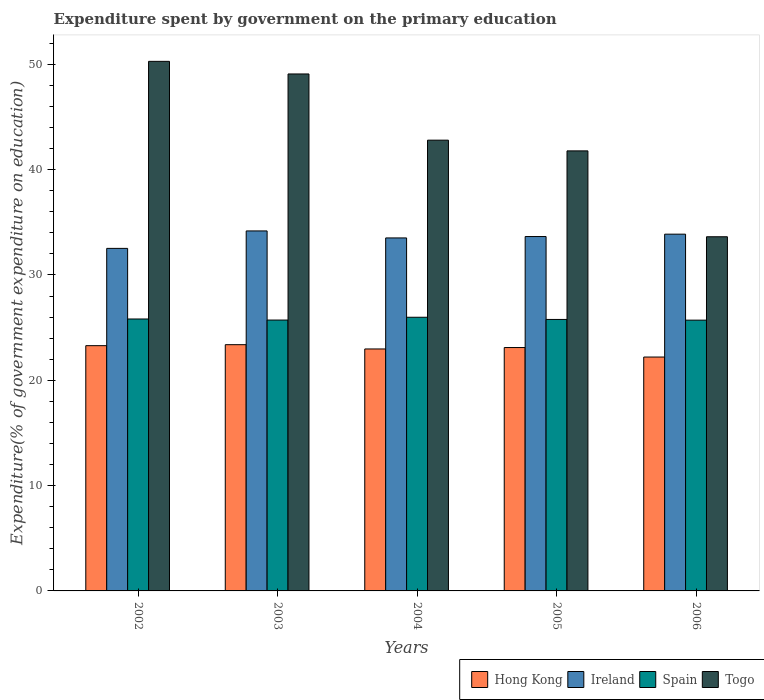How many groups of bars are there?
Offer a terse response. 5. Are the number of bars per tick equal to the number of legend labels?
Offer a very short reply. Yes. How many bars are there on the 1st tick from the left?
Provide a short and direct response. 4. What is the label of the 5th group of bars from the left?
Provide a short and direct response. 2006. In how many cases, is the number of bars for a given year not equal to the number of legend labels?
Your response must be concise. 0. What is the expenditure spent by government on the primary education in Ireland in 2002?
Offer a terse response. 32.52. Across all years, what is the maximum expenditure spent by government on the primary education in Togo?
Offer a terse response. 50.28. Across all years, what is the minimum expenditure spent by government on the primary education in Togo?
Provide a short and direct response. 33.63. In which year was the expenditure spent by government on the primary education in Togo maximum?
Provide a short and direct response. 2002. In which year was the expenditure spent by government on the primary education in Ireland minimum?
Ensure brevity in your answer.  2002. What is the total expenditure spent by government on the primary education in Ireland in the graph?
Offer a terse response. 167.73. What is the difference between the expenditure spent by government on the primary education in Ireland in 2002 and that in 2004?
Your answer should be compact. -0.99. What is the difference between the expenditure spent by government on the primary education in Hong Kong in 2005 and the expenditure spent by government on the primary education in Ireland in 2004?
Keep it short and to the point. -10.41. What is the average expenditure spent by government on the primary education in Togo per year?
Offer a very short reply. 43.51. In the year 2005, what is the difference between the expenditure spent by government on the primary education in Hong Kong and expenditure spent by government on the primary education in Togo?
Your response must be concise. -18.67. In how many years, is the expenditure spent by government on the primary education in Spain greater than 32 %?
Your answer should be compact. 0. What is the ratio of the expenditure spent by government on the primary education in Hong Kong in 2003 to that in 2006?
Make the answer very short. 1.05. Is the expenditure spent by government on the primary education in Hong Kong in 2002 less than that in 2003?
Make the answer very short. Yes. What is the difference between the highest and the second highest expenditure spent by government on the primary education in Hong Kong?
Keep it short and to the point. 0.09. What is the difference between the highest and the lowest expenditure spent by government on the primary education in Spain?
Ensure brevity in your answer.  0.28. Is the sum of the expenditure spent by government on the primary education in Ireland in 2003 and 2006 greater than the maximum expenditure spent by government on the primary education in Togo across all years?
Offer a very short reply. Yes. What does the 3rd bar from the left in 2004 represents?
Your response must be concise. Spain. What does the 4th bar from the right in 2004 represents?
Your answer should be very brief. Hong Kong. How many bars are there?
Give a very brief answer. 20. Are all the bars in the graph horizontal?
Make the answer very short. No. How many legend labels are there?
Your response must be concise. 4. How are the legend labels stacked?
Give a very brief answer. Horizontal. What is the title of the graph?
Your response must be concise. Expenditure spent by government on the primary education. Does "Ghana" appear as one of the legend labels in the graph?
Make the answer very short. No. What is the label or title of the Y-axis?
Your answer should be very brief. Expenditure(% of government expenditure on education). What is the Expenditure(% of government expenditure on education) in Hong Kong in 2002?
Give a very brief answer. 23.29. What is the Expenditure(% of government expenditure on education) of Ireland in 2002?
Provide a succinct answer. 32.52. What is the Expenditure(% of government expenditure on education) in Spain in 2002?
Provide a short and direct response. 25.82. What is the Expenditure(% of government expenditure on education) of Togo in 2002?
Provide a succinct answer. 50.28. What is the Expenditure(% of government expenditure on education) in Hong Kong in 2003?
Keep it short and to the point. 23.38. What is the Expenditure(% of government expenditure on education) of Ireland in 2003?
Offer a terse response. 34.18. What is the Expenditure(% of government expenditure on education) in Spain in 2003?
Ensure brevity in your answer.  25.72. What is the Expenditure(% of government expenditure on education) in Togo in 2003?
Your answer should be very brief. 49.08. What is the Expenditure(% of government expenditure on education) of Hong Kong in 2004?
Offer a terse response. 22.97. What is the Expenditure(% of government expenditure on education) in Ireland in 2004?
Offer a terse response. 33.51. What is the Expenditure(% of government expenditure on education) in Spain in 2004?
Ensure brevity in your answer.  25.98. What is the Expenditure(% of government expenditure on education) of Togo in 2004?
Offer a terse response. 42.8. What is the Expenditure(% of government expenditure on education) in Hong Kong in 2005?
Your answer should be compact. 23.11. What is the Expenditure(% of government expenditure on education) of Ireland in 2005?
Make the answer very short. 33.65. What is the Expenditure(% of government expenditure on education) in Spain in 2005?
Ensure brevity in your answer.  25.77. What is the Expenditure(% of government expenditure on education) of Togo in 2005?
Give a very brief answer. 41.78. What is the Expenditure(% of government expenditure on education) in Hong Kong in 2006?
Make the answer very short. 22.21. What is the Expenditure(% of government expenditure on education) in Ireland in 2006?
Ensure brevity in your answer.  33.87. What is the Expenditure(% of government expenditure on education) of Spain in 2006?
Ensure brevity in your answer.  25.71. What is the Expenditure(% of government expenditure on education) of Togo in 2006?
Keep it short and to the point. 33.63. Across all years, what is the maximum Expenditure(% of government expenditure on education) in Hong Kong?
Provide a succinct answer. 23.38. Across all years, what is the maximum Expenditure(% of government expenditure on education) of Ireland?
Provide a short and direct response. 34.18. Across all years, what is the maximum Expenditure(% of government expenditure on education) of Spain?
Provide a short and direct response. 25.98. Across all years, what is the maximum Expenditure(% of government expenditure on education) in Togo?
Provide a succinct answer. 50.28. Across all years, what is the minimum Expenditure(% of government expenditure on education) of Hong Kong?
Provide a succinct answer. 22.21. Across all years, what is the minimum Expenditure(% of government expenditure on education) of Ireland?
Offer a terse response. 32.52. Across all years, what is the minimum Expenditure(% of government expenditure on education) of Spain?
Your answer should be compact. 25.71. Across all years, what is the minimum Expenditure(% of government expenditure on education) in Togo?
Offer a terse response. 33.63. What is the total Expenditure(% of government expenditure on education) in Hong Kong in the graph?
Your answer should be compact. 114.95. What is the total Expenditure(% of government expenditure on education) in Ireland in the graph?
Your response must be concise. 167.73. What is the total Expenditure(% of government expenditure on education) of Spain in the graph?
Keep it short and to the point. 129. What is the total Expenditure(% of government expenditure on education) of Togo in the graph?
Give a very brief answer. 217.56. What is the difference between the Expenditure(% of government expenditure on education) in Hong Kong in 2002 and that in 2003?
Ensure brevity in your answer.  -0.09. What is the difference between the Expenditure(% of government expenditure on education) in Ireland in 2002 and that in 2003?
Offer a very short reply. -1.66. What is the difference between the Expenditure(% of government expenditure on education) of Spain in 2002 and that in 2003?
Give a very brief answer. 0.1. What is the difference between the Expenditure(% of government expenditure on education) of Togo in 2002 and that in 2003?
Make the answer very short. 1.2. What is the difference between the Expenditure(% of government expenditure on education) in Hong Kong in 2002 and that in 2004?
Your answer should be compact. 0.31. What is the difference between the Expenditure(% of government expenditure on education) in Ireland in 2002 and that in 2004?
Offer a terse response. -0.99. What is the difference between the Expenditure(% of government expenditure on education) of Spain in 2002 and that in 2004?
Give a very brief answer. -0.16. What is the difference between the Expenditure(% of government expenditure on education) of Togo in 2002 and that in 2004?
Keep it short and to the point. 7.48. What is the difference between the Expenditure(% of government expenditure on education) in Hong Kong in 2002 and that in 2005?
Your answer should be very brief. 0.18. What is the difference between the Expenditure(% of government expenditure on education) in Ireland in 2002 and that in 2005?
Provide a short and direct response. -1.12. What is the difference between the Expenditure(% of government expenditure on education) of Spain in 2002 and that in 2005?
Your answer should be very brief. 0.04. What is the difference between the Expenditure(% of government expenditure on education) of Togo in 2002 and that in 2005?
Ensure brevity in your answer.  8.5. What is the difference between the Expenditure(% of government expenditure on education) of Hong Kong in 2002 and that in 2006?
Offer a terse response. 1.08. What is the difference between the Expenditure(% of government expenditure on education) in Ireland in 2002 and that in 2006?
Offer a very short reply. -1.35. What is the difference between the Expenditure(% of government expenditure on education) of Togo in 2002 and that in 2006?
Offer a terse response. 16.65. What is the difference between the Expenditure(% of government expenditure on education) of Hong Kong in 2003 and that in 2004?
Give a very brief answer. 0.41. What is the difference between the Expenditure(% of government expenditure on education) of Ireland in 2003 and that in 2004?
Ensure brevity in your answer.  0.66. What is the difference between the Expenditure(% of government expenditure on education) of Spain in 2003 and that in 2004?
Your answer should be compact. -0.27. What is the difference between the Expenditure(% of government expenditure on education) in Togo in 2003 and that in 2004?
Provide a succinct answer. 6.29. What is the difference between the Expenditure(% of government expenditure on education) of Hong Kong in 2003 and that in 2005?
Keep it short and to the point. 0.27. What is the difference between the Expenditure(% of government expenditure on education) of Ireland in 2003 and that in 2005?
Provide a short and direct response. 0.53. What is the difference between the Expenditure(% of government expenditure on education) in Spain in 2003 and that in 2005?
Give a very brief answer. -0.06. What is the difference between the Expenditure(% of government expenditure on education) in Togo in 2003 and that in 2005?
Your answer should be compact. 7.3. What is the difference between the Expenditure(% of government expenditure on education) of Hong Kong in 2003 and that in 2006?
Make the answer very short. 1.17. What is the difference between the Expenditure(% of government expenditure on education) of Ireland in 2003 and that in 2006?
Make the answer very short. 0.31. What is the difference between the Expenditure(% of government expenditure on education) in Spain in 2003 and that in 2006?
Your answer should be compact. 0.01. What is the difference between the Expenditure(% of government expenditure on education) of Togo in 2003 and that in 2006?
Make the answer very short. 15.46. What is the difference between the Expenditure(% of government expenditure on education) of Hong Kong in 2004 and that in 2005?
Provide a succinct answer. -0.13. What is the difference between the Expenditure(% of government expenditure on education) of Ireland in 2004 and that in 2005?
Offer a very short reply. -0.13. What is the difference between the Expenditure(% of government expenditure on education) in Spain in 2004 and that in 2005?
Offer a terse response. 0.21. What is the difference between the Expenditure(% of government expenditure on education) in Hong Kong in 2004 and that in 2006?
Provide a succinct answer. 0.77. What is the difference between the Expenditure(% of government expenditure on education) of Ireland in 2004 and that in 2006?
Your response must be concise. -0.36. What is the difference between the Expenditure(% of government expenditure on education) in Spain in 2004 and that in 2006?
Make the answer very short. 0.28. What is the difference between the Expenditure(% of government expenditure on education) in Togo in 2004 and that in 2006?
Make the answer very short. 9.17. What is the difference between the Expenditure(% of government expenditure on education) of Hong Kong in 2005 and that in 2006?
Provide a short and direct response. 0.9. What is the difference between the Expenditure(% of government expenditure on education) in Ireland in 2005 and that in 2006?
Offer a terse response. -0.23. What is the difference between the Expenditure(% of government expenditure on education) of Spain in 2005 and that in 2006?
Your answer should be very brief. 0.07. What is the difference between the Expenditure(% of government expenditure on education) in Togo in 2005 and that in 2006?
Keep it short and to the point. 8.15. What is the difference between the Expenditure(% of government expenditure on education) of Hong Kong in 2002 and the Expenditure(% of government expenditure on education) of Ireland in 2003?
Provide a succinct answer. -10.89. What is the difference between the Expenditure(% of government expenditure on education) in Hong Kong in 2002 and the Expenditure(% of government expenditure on education) in Spain in 2003?
Your answer should be very brief. -2.43. What is the difference between the Expenditure(% of government expenditure on education) of Hong Kong in 2002 and the Expenditure(% of government expenditure on education) of Togo in 2003?
Keep it short and to the point. -25.8. What is the difference between the Expenditure(% of government expenditure on education) in Ireland in 2002 and the Expenditure(% of government expenditure on education) in Spain in 2003?
Provide a succinct answer. 6.81. What is the difference between the Expenditure(% of government expenditure on education) in Ireland in 2002 and the Expenditure(% of government expenditure on education) in Togo in 2003?
Provide a short and direct response. -16.56. What is the difference between the Expenditure(% of government expenditure on education) in Spain in 2002 and the Expenditure(% of government expenditure on education) in Togo in 2003?
Keep it short and to the point. -23.26. What is the difference between the Expenditure(% of government expenditure on education) in Hong Kong in 2002 and the Expenditure(% of government expenditure on education) in Ireland in 2004?
Your response must be concise. -10.23. What is the difference between the Expenditure(% of government expenditure on education) in Hong Kong in 2002 and the Expenditure(% of government expenditure on education) in Spain in 2004?
Make the answer very short. -2.7. What is the difference between the Expenditure(% of government expenditure on education) in Hong Kong in 2002 and the Expenditure(% of government expenditure on education) in Togo in 2004?
Ensure brevity in your answer.  -19.51. What is the difference between the Expenditure(% of government expenditure on education) of Ireland in 2002 and the Expenditure(% of government expenditure on education) of Spain in 2004?
Offer a terse response. 6.54. What is the difference between the Expenditure(% of government expenditure on education) of Ireland in 2002 and the Expenditure(% of government expenditure on education) of Togo in 2004?
Offer a very short reply. -10.27. What is the difference between the Expenditure(% of government expenditure on education) of Spain in 2002 and the Expenditure(% of government expenditure on education) of Togo in 2004?
Your answer should be compact. -16.98. What is the difference between the Expenditure(% of government expenditure on education) in Hong Kong in 2002 and the Expenditure(% of government expenditure on education) in Ireland in 2005?
Your answer should be compact. -10.36. What is the difference between the Expenditure(% of government expenditure on education) in Hong Kong in 2002 and the Expenditure(% of government expenditure on education) in Spain in 2005?
Offer a terse response. -2.49. What is the difference between the Expenditure(% of government expenditure on education) in Hong Kong in 2002 and the Expenditure(% of government expenditure on education) in Togo in 2005?
Make the answer very short. -18.49. What is the difference between the Expenditure(% of government expenditure on education) in Ireland in 2002 and the Expenditure(% of government expenditure on education) in Spain in 2005?
Make the answer very short. 6.75. What is the difference between the Expenditure(% of government expenditure on education) of Ireland in 2002 and the Expenditure(% of government expenditure on education) of Togo in 2005?
Your answer should be very brief. -9.26. What is the difference between the Expenditure(% of government expenditure on education) of Spain in 2002 and the Expenditure(% of government expenditure on education) of Togo in 2005?
Provide a succinct answer. -15.96. What is the difference between the Expenditure(% of government expenditure on education) in Hong Kong in 2002 and the Expenditure(% of government expenditure on education) in Ireland in 2006?
Provide a succinct answer. -10.59. What is the difference between the Expenditure(% of government expenditure on education) in Hong Kong in 2002 and the Expenditure(% of government expenditure on education) in Spain in 2006?
Your response must be concise. -2.42. What is the difference between the Expenditure(% of government expenditure on education) in Hong Kong in 2002 and the Expenditure(% of government expenditure on education) in Togo in 2006?
Your answer should be very brief. -10.34. What is the difference between the Expenditure(% of government expenditure on education) of Ireland in 2002 and the Expenditure(% of government expenditure on education) of Spain in 2006?
Keep it short and to the point. 6.81. What is the difference between the Expenditure(% of government expenditure on education) of Ireland in 2002 and the Expenditure(% of government expenditure on education) of Togo in 2006?
Your answer should be compact. -1.1. What is the difference between the Expenditure(% of government expenditure on education) of Spain in 2002 and the Expenditure(% of government expenditure on education) of Togo in 2006?
Ensure brevity in your answer.  -7.81. What is the difference between the Expenditure(% of government expenditure on education) in Hong Kong in 2003 and the Expenditure(% of government expenditure on education) in Ireland in 2004?
Provide a succinct answer. -10.13. What is the difference between the Expenditure(% of government expenditure on education) in Hong Kong in 2003 and the Expenditure(% of government expenditure on education) in Spain in 2004?
Make the answer very short. -2.6. What is the difference between the Expenditure(% of government expenditure on education) in Hong Kong in 2003 and the Expenditure(% of government expenditure on education) in Togo in 2004?
Your response must be concise. -19.42. What is the difference between the Expenditure(% of government expenditure on education) in Ireland in 2003 and the Expenditure(% of government expenditure on education) in Spain in 2004?
Give a very brief answer. 8.2. What is the difference between the Expenditure(% of government expenditure on education) in Ireland in 2003 and the Expenditure(% of government expenditure on education) in Togo in 2004?
Give a very brief answer. -8.62. What is the difference between the Expenditure(% of government expenditure on education) in Spain in 2003 and the Expenditure(% of government expenditure on education) in Togo in 2004?
Offer a very short reply. -17.08. What is the difference between the Expenditure(% of government expenditure on education) of Hong Kong in 2003 and the Expenditure(% of government expenditure on education) of Ireland in 2005?
Give a very brief answer. -10.27. What is the difference between the Expenditure(% of government expenditure on education) in Hong Kong in 2003 and the Expenditure(% of government expenditure on education) in Spain in 2005?
Provide a succinct answer. -2.4. What is the difference between the Expenditure(% of government expenditure on education) of Hong Kong in 2003 and the Expenditure(% of government expenditure on education) of Togo in 2005?
Offer a terse response. -18.4. What is the difference between the Expenditure(% of government expenditure on education) of Ireland in 2003 and the Expenditure(% of government expenditure on education) of Spain in 2005?
Offer a terse response. 8.4. What is the difference between the Expenditure(% of government expenditure on education) of Ireland in 2003 and the Expenditure(% of government expenditure on education) of Togo in 2005?
Provide a short and direct response. -7.6. What is the difference between the Expenditure(% of government expenditure on education) in Spain in 2003 and the Expenditure(% of government expenditure on education) in Togo in 2005?
Offer a very short reply. -16.06. What is the difference between the Expenditure(% of government expenditure on education) of Hong Kong in 2003 and the Expenditure(% of government expenditure on education) of Ireland in 2006?
Keep it short and to the point. -10.49. What is the difference between the Expenditure(% of government expenditure on education) of Hong Kong in 2003 and the Expenditure(% of government expenditure on education) of Spain in 2006?
Ensure brevity in your answer.  -2.33. What is the difference between the Expenditure(% of government expenditure on education) in Hong Kong in 2003 and the Expenditure(% of government expenditure on education) in Togo in 2006?
Your answer should be very brief. -10.25. What is the difference between the Expenditure(% of government expenditure on education) in Ireland in 2003 and the Expenditure(% of government expenditure on education) in Spain in 2006?
Make the answer very short. 8.47. What is the difference between the Expenditure(% of government expenditure on education) in Ireland in 2003 and the Expenditure(% of government expenditure on education) in Togo in 2006?
Your answer should be compact. 0.55. What is the difference between the Expenditure(% of government expenditure on education) in Spain in 2003 and the Expenditure(% of government expenditure on education) in Togo in 2006?
Your response must be concise. -7.91. What is the difference between the Expenditure(% of government expenditure on education) of Hong Kong in 2004 and the Expenditure(% of government expenditure on education) of Ireland in 2005?
Make the answer very short. -10.67. What is the difference between the Expenditure(% of government expenditure on education) of Hong Kong in 2004 and the Expenditure(% of government expenditure on education) of Spain in 2005?
Your answer should be compact. -2.8. What is the difference between the Expenditure(% of government expenditure on education) in Hong Kong in 2004 and the Expenditure(% of government expenditure on education) in Togo in 2005?
Give a very brief answer. -18.81. What is the difference between the Expenditure(% of government expenditure on education) of Ireland in 2004 and the Expenditure(% of government expenditure on education) of Spain in 2005?
Offer a very short reply. 7.74. What is the difference between the Expenditure(% of government expenditure on education) in Ireland in 2004 and the Expenditure(% of government expenditure on education) in Togo in 2005?
Your answer should be compact. -8.26. What is the difference between the Expenditure(% of government expenditure on education) of Spain in 2004 and the Expenditure(% of government expenditure on education) of Togo in 2005?
Provide a short and direct response. -15.8. What is the difference between the Expenditure(% of government expenditure on education) in Hong Kong in 2004 and the Expenditure(% of government expenditure on education) in Ireland in 2006?
Your response must be concise. -10.9. What is the difference between the Expenditure(% of government expenditure on education) in Hong Kong in 2004 and the Expenditure(% of government expenditure on education) in Spain in 2006?
Offer a very short reply. -2.73. What is the difference between the Expenditure(% of government expenditure on education) of Hong Kong in 2004 and the Expenditure(% of government expenditure on education) of Togo in 2006?
Ensure brevity in your answer.  -10.65. What is the difference between the Expenditure(% of government expenditure on education) in Ireland in 2004 and the Expenditure(% of government expenditure on education) in Spain in 2006?
Ensure brevity in your answer.  7.81. What is the difference between the Expenditure(% of government expenditure on education) of Ireland in 2004 and the Expenditure(% of government expenditure on education) of Togo in 2006?
Offer a very short reply. -0.11. What is the difference between the Expenditure(% of government expenditure on education) in Spain in 2004 and the Expenditure(% of government expenditure on education) in Togo in 2006?
Your answer should be compact. -7.64. What is the difference between the Expenditure(% of government expenditure on education) of Hong Kong in 2005 and the Expenditure(% of government expenditure on education) of Ireland in 2006?
Your answer should be very brief. -10.76. What is the difference between the Expenditure(% of government expenditure on education) in Hong Kong in 2005 and the Expenditure(% of government expenditure on education) in Spain in 2006?
Give a very brief answer. -2.6. What is the difference between the Expenditure(% of government expenditure on education) of Hong Kong in 2005 and the Expenditure(% of government expenditure on education) of Togo in 2006?
Your answer should be very brief. -10.52. What is the difference between the Expenditure(% of government expenditure on education) in Ireland in 2005 and the Expenditure(% of government expenditure on education) in Spain in 2006?
Make the answer very short. 7.94. What is the difference between the Expenditure(% of government expenditure on education) of Ireland in 2005 and the Expenditure(% of government expenditure on education) of Togo in 2006?
Provide a succinct answer. 0.02. What is the difference between the Expenditure(% of government expenditure on education) in Spain in 2005 and the Expenditure(% of government expenditure on education) in Togo in 2006?
Your answer should be very brief. -7.85. What is the average Expenditure(% of government expenditure on education) of Hong Kong per year?
Offer a very short reply. 22.99. What is the average Expenditure(% of government expenditure on education) in Ireland per year?
Provide a succinct answer. 33.55. What is the average Expenditure(% of government expenditure on education) in Spain per year?
Your answer should be very brief. 25.8. What is the average Expenditure(% of government expenditure on education) in Togo per year?
Your answer should be compact. 43.51. In the year 2002, what is the difference between the Expenditure(% of government expenditure on education) in Hong Kong and Expenditure(% of government expenditure on education) in Ireland?
Your response must be concise. -9.24. In the year 2002, what is the difference between the Expenditure(% of government expenditure on education) of Hong Kong and Expenditure(% of government expenditure on education) of Spain?
Make the answer very short. -2.53. In the year 2002, what is the difference between the Expenditure(% of government expenditure on education) in Hong Kong and Expenditure(% of government expenditure on education) in Togo?
Give a very brief answer. -26.99. In the year 2002, what is the difference between the Expenditure(% of government expenditure on education) in Ireland and Expenditure(% of government expenditure on education) in Spain?
Offer a very short reply. 6.7. In the year 2002, what is the difference between the Expenditure(% of government expenditure on education) of Ireland and Expenditure(% of government expenditure on education) of Togo?
Make the answer very short. -17.76. In the year 2002, what is the difference between the Expenditure(% of government expenditure on education) of Spain and Expenditure(% of government expenditure on education) of Togo?
Give a very brief answer. -24.46. In the year 2003, what is the difference between the Expenditure(% of government expenditure on education) in Hong Kong and Expenditure(% of government expenditure on education) in Ireland?
Keep it short and to the point. -10.8. In the year 2003, what is the difference between the Expenditure(% of government expenditure on education) of Hong Kong and Expenditure(% of government expenditure on education) of Spain?
Your answer should be very brief. -2.34. In the year 2003, what is the difference between the Expenditure(% of government expenditure on education) of Hong Kong and Expenditure(% of government expenditure on education) of Togo?
Ensure brevity in your answer.  -25.7. In the year 2003, what is the difference between the Expenditure(% of government expenditure on education) of Ireland and Expenditure(% of government expenditure on education) of Spain?
Your answer should be very brief. 8.46. In the year 2003, what is the difference between the Expenditure(% of government expenditure on education) of Ireland and Expenditure(% of government expenditure on education) of Togo?
Give a very brief answer. -14.9. In the year 2003, what is the difference between the Expenditure(% of government expenditure on education) of Spain and Expenditure(% of government expenditure on education) of Togo?
Offer a very short reply. -23.36. In the year 2004, what is the difference between the Expenditure(% of government expenditure on education) in Hong Kong and Expenditure(% of government expenditure on education) in Ireland?
Provide a succinct answer. -10.54. In the year 2004, what is the difference between the Expenditure(% of government expenditure on education) in Hong Kong and Expenditure(% of government expenditure on education) in Spain?
Your answer should be very brief. -3.01. In the year 2004, what is the difference between the Expenditure(% of government expenditure on education) of Hong Kong and Expenditure(% of government expenditure on education) of Togo?
Give a very brief answer. -19.82. In the year 2004, what is the difference between the Expenditure(% of government expenditure on education) in Ireland and Expenditure(% of government expenditure on education) in Spain?
Offer a very short reply. 7.53. In the year 2004, what is the difference between the Expenditure(% of government expenditure on education) of Ireland and Expenditure(% of government expenditure on education) of Togo?
Provide a short and direct response. -9.28. In the year 2004, what is the difference between the Expenditure(% of government expenditure on education) of Spain and Expenditure(% of government expenditure on education) of Togo?
Keep it short and to the point. -16.81. In the year 2005, what is the difference between the Expenditure(% of government expenditure on education) in Hong Kong and Expenditure(% of government expenditure on education) in Ireland?
Your answer should be compact. -10.54. In the year 2005, what is the difference between the Expenditure(% of government expenditure on education) of Hong Kong and Expenditure(% of government expenditure on education) of Spain?
Keep it short and to the point. -2.67. In the year 2005, what is the difference between the Expenditure(% of government expenditure on education) of Hong Kong and Expenditure(% of government expenditure on education) of Togo?
Offer a very short reply. -18.67. In the year 2005, what is the difference between the Expenditure(% of government expenditure on education) of Ireland and Expenditure(% of government expenditure on education) of Spain?
Offer a very short reply. 7.87. In the year 2005, what is the difference between the Expenditure(% of government expenditure on education) of Ireland and Expenditure(% of government expenditure on education) of Togo?
Provide a short and direct response. -8.13. In the year 2005, what is the difference between the Expenditure(% of government expenditure on education) in Spain and Expenditure(% of government expenditure on education) in Togo?
Your response must be concise. -16. In the year 2006, what is the difference between the Expenditure(% of government expenditure on education) of Hong Kong and Expenditure(% of government expenditure on education) of Ireland?
Your answer should be very brief. -11.67. In the year 2006, what is the difference between the Expenditure(% of government expenditure on education) of Hong Kong and Expenditure(% of government expenditure on education) of Spain?
Your response must be concise. -3.5. In the year 2006, what is the difference between the Expenditure(% of government expenditure on education) of Hong Kong and Expenditure(% of government expenditure on education) of Togo?
Your response must be concise. -11.42. In the year 2006, what is the difference between the Expenditure(% of government expenditure on education) in Ireland and Expenditure(% of government expenditure on education) in Spain?
Your answer should be very brief. 8.16. In the year 2006, what is the difference between the Expenditure(% of government expenditure on education) in Ireland and Expenditure(% of government expenditure on education) in Togo?
Your answer should be compact. 0.25. In the year 2006, what is the difference between the Expenditure(% of government expenditure on education) of Spain and Expenditure(% of government expenditure on education) of Togo?
Keep it short and to the point. -7.92. What is the ratio of the Expenditure(% of government expenditure on education) of Hong Kong in 2002 to that in 2003?
Keep it short and to the point. 1. What is the ratio of the Expenditure(% of government expenditure on education) in Ireland in 2002 to that in 2003?
Provide a short and direct response. 0.95. What is the ratio of the Expenditure(% of government expenditure on education) of Togo in 2002 to that in 2003?
Provide a short and direct response. 1.02. What is the ratio of the Expenditure(% of government expenditure on education) of Hong Kong in 2002 to that in 2004?
Provide a succinct answer. 1.01. What is the ratio of the Expenditure(% of government expenditure on education) in Ireland in 2002 to that in 2004?
Your answer should be compact. 0.97. What is the ratio of the Expenditure(% of government expenditure on education) of Togo in 2002 to that in 2004?
Give a very brief answer. 1.17. What is the ratio of the Expenditure(% of government expenditure on education) of Hong Kong in 2002 to that in 2005?
Your answer should be compact. 1.01. What is the ratio of the Expenditure(% of government expenditure on education) in Ireland in 2002 to that in 2005?
Give a very brief answer. 0.97. What is the ratio of the Expenditure(% of government expenditure on education) of Spain in 2002 to that in 2005?
Your answer should be compact. 1. What is the ratio of the Expenditure(% of government expenditure on education) of Togo in 2002 to that in 2005?
Your answer should be very brief. 1.2. What is the ratio of the Expenditure(% of government expenditure on education) in Hong Kong in 2002 to that in 2006?
Make the answer very short. 1.05. What is the ratio of the Expenditure(% of government expenditure on education) in Ireland in 2002 to that in 2006?
Offer a very short reply. 0.96. What is the ratio of the Expenditure(% of government expenditure on education) in Spain in 2002 to that in 2006?
Offer a very short reply. 1. What is the ratio of the Expenditure(% of government expenditure on education) of Togo in 2002 to that in 2006?
Offer a very short reply. 1.5. What is the ratio of the Expenditure(% of government expenditure on education) in Hong Kong in 2003 to that in 2004?
Provide a succinct answer. 1.02. What is the ratio of the Expenditure(% of government expenditure on education) of Ireland in 2003 to that in 2004?
Offer a terse response. 1.02. What is the ratio of the Expenditure(% of government expenditure on education) of Togo in 2003 to that in 2004?
Ensure brevity in your answer.  1.15. What is the ratio of the Expenditure(% of government expenditure on education) in Hong Kong in 2003 to that in 2005?
Your answer should be very brief. 1.01. What is the ratio of the Expenditure(% of government expenditure on education) of Ireland in 2003 to that in 2005?
Ensure brevity in your answer.  1.02. What is the ratio of the Expenditure(% of government expenditure on education) of Spain in 2003 to that in 2005?
Offer a terse response. 1. What is the ratio of the Expenditure(% of government expenditure on education) of Togo in 2003 to that in 2005?
Keep it short and to the point. 1.17. What is the ratio of the Expenditure(% of government expenditure on education) in Hong Kong in 2003 to that in 2006?
Your answer should be very brief. 1.05. What is the ratio of the Expenditure(% of government expenditure on education) in Ireland in 2003 to that in 2006?
Ensure brevity in your answer.  1.01. What is the ratio of the Expenditure(% of government expenditure on education) in Spain in 2003 to that in 2006?
Offer a terse response. 1. What is the ratio of the Expenditure(% of government expenditure on education) of Togo in 2003 to that in 2006?
Offer a very short reply. 1.46. What is the ratio of the Expenditure(% of government expenditure on education) in Togo in 2004 to that in 2005?
Offer a terse response. 1.02. What is the ratio of the Expenditure(% of government expenditure on education) of Hong Kong in 2004 to that in 2006?
Your answer should be compact. 1.03. What is the ratio of the Expenditure(% of government expenditure on education) in Spain in 2004 to that in 2006?
Offer a terse response. 1.01. What is the ratio of the Expenditure(% of government expenditure on education) in Togo in 2004 to that in 2006?
Provide a short and direct response. 1.27. What is the ratio of the Expenditure(% of government expenditure on education) of Hong Kong in 2005 to that in 2006?
Your response must be concise. 1.04. What is the ratio of the Expenditure(% of government expenditure on education) of Ireland in 2005 to that in 2006?
Your answer should be very brief. 0.99. What is the ratio of the Expenditure(% of government expenditure on education) of Togo in 2005 to that in 2006?
Your response must be concise. 1.24. What is the difference between the highest and the second highest Expenditure(% of government expenditure on education) in Hong Kong?
Give a very brief answer. 0.09. What is the difference between the highest and the second highest Expenditure(% of government expenditure on education) of Ireland?
Keep it short and to the point. 0.31. What is the difference between the highest and the second highest Expenditure(% of government expenditure on education) of Spain?
Provide a succinct answer. 0.16. What is the difference between the highest and the second highest Expenditure(% of government expenditure on education) in Togo?
Provide a succinct answer. 1.2. What is the difference between the highest and the lowest Expenditure(% of government expenditure on education) in Hong Kong?
Your answer should be very brief. 1.17. What is the difference between the highest and the lowest Expenditure(% of government expenditure on education) in Ireland?
Offer a terse response. 1.66. What is the difference between the highest and the lowest Expenditure(% of government expenditure on education) of Spain?
Ensure brevity in your answer.  0.28. What is the difference between the highest and the lowest Expenditure(% of government expenditure on education) in Togo?
Provide a succinct answer. 16.65. 